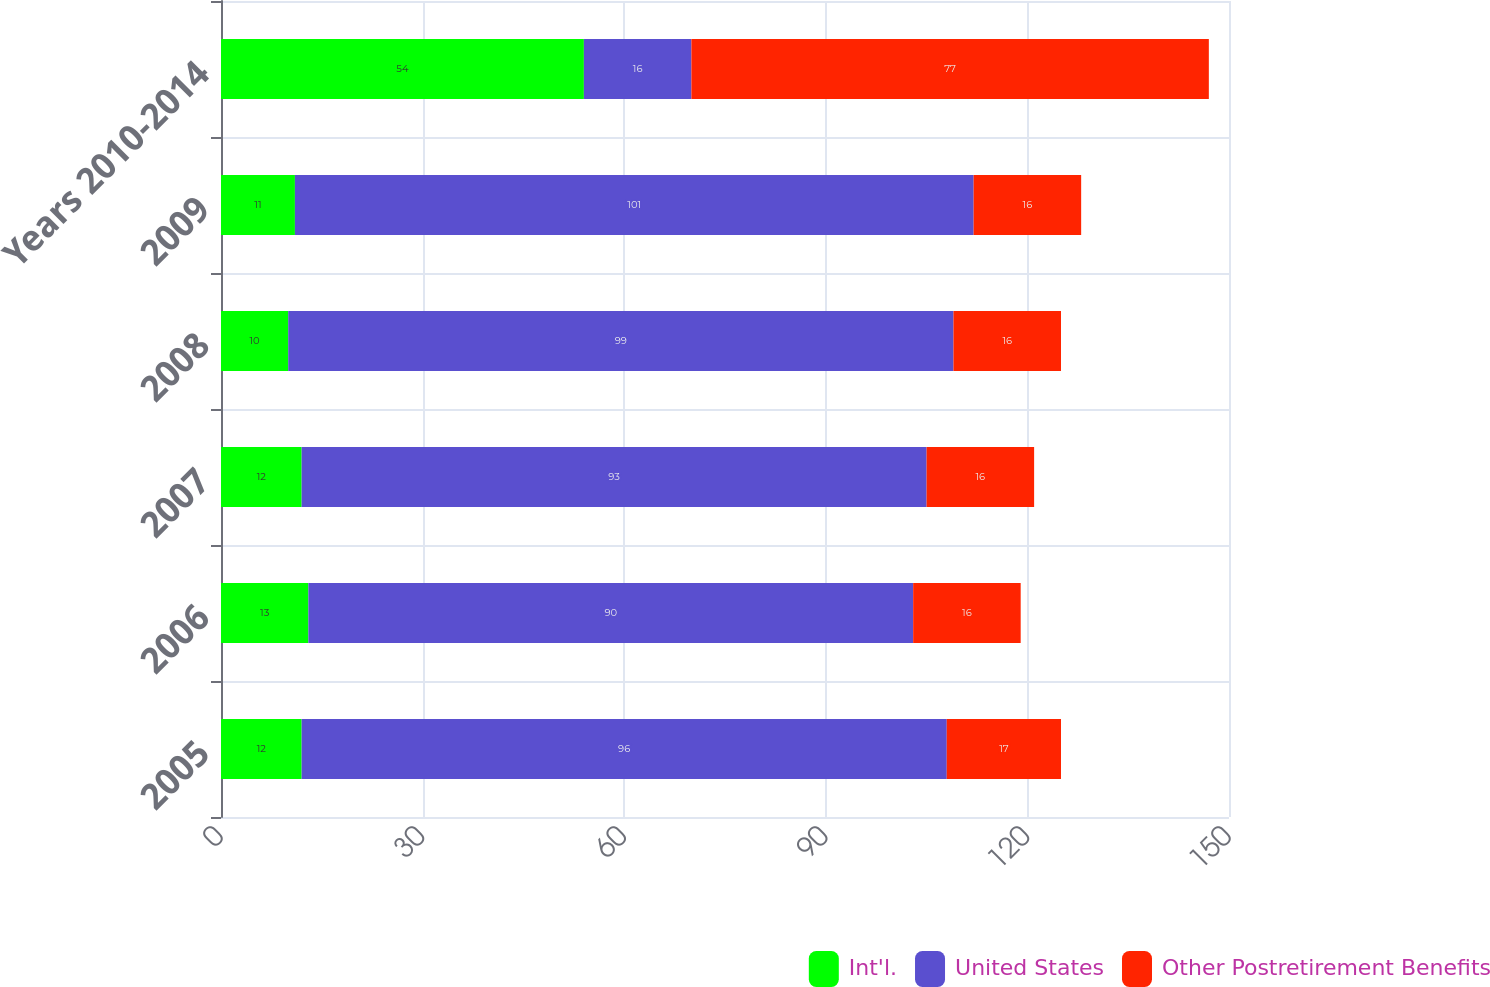<chart> <loc_0><loc_0><loc_500><loc_500><stacked_bar_chart><ecel><fcel>2005<fcel>2006<fcel>2007<fcel>2008<fcel>2009<fcel>Years 2010-2014<nl><fcel>Int'l.<fcel>12<fcel>13<fcel>12<fcel>10<fcel>11<fcel>54<nl><fcel>United States<fcel>96<fcel>90<fcel>93<fcel>99<fcel>101<fcel>16<nl><fcel>Other Postretirement Benefits<fcel>17<fcel>16<fcel>16<fcel>16<fcel>16<fcel>77<nl></chart> 